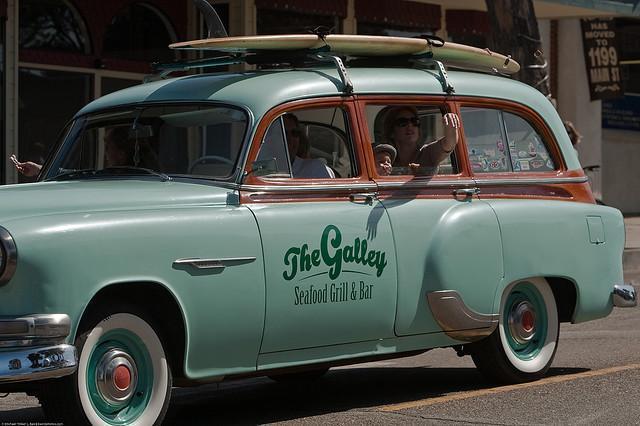Which one of these natural disasters might this car get caught in?
Choose the correct response and explain in the format: 'Answer: answer
Rationale: rationale.'
Options: Blizzard, volcano, monsoon, earthquake. Answer: earthquake.
Rationale: California has plenty of earthquakes and california is a surf state. 